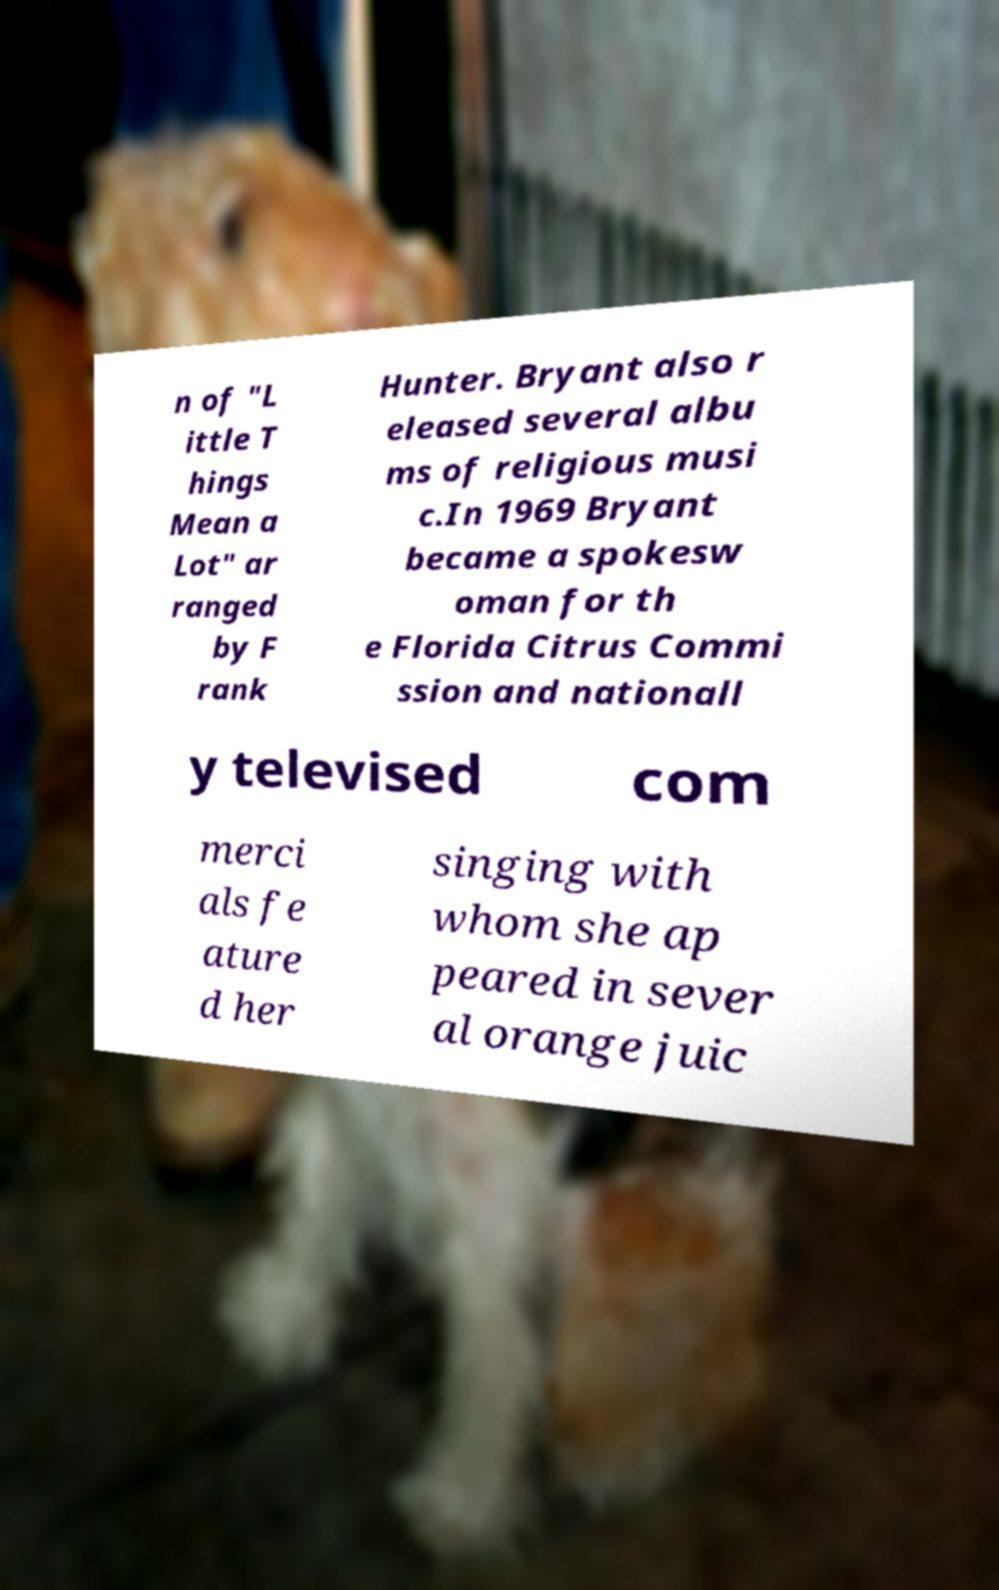Could you extract and type out the text from this image? n of "L ittle T hings Mean a Lot" ar ranged by F rank Hunter. Bryant also r eleased several albu ms of religious musi c.In 1969 Bryant became a spokesw oman for th e Florida Citrus Commi ssion and nationall y televised com merci als fe ature d her singing with whom she ap peared in sever al orange juic 